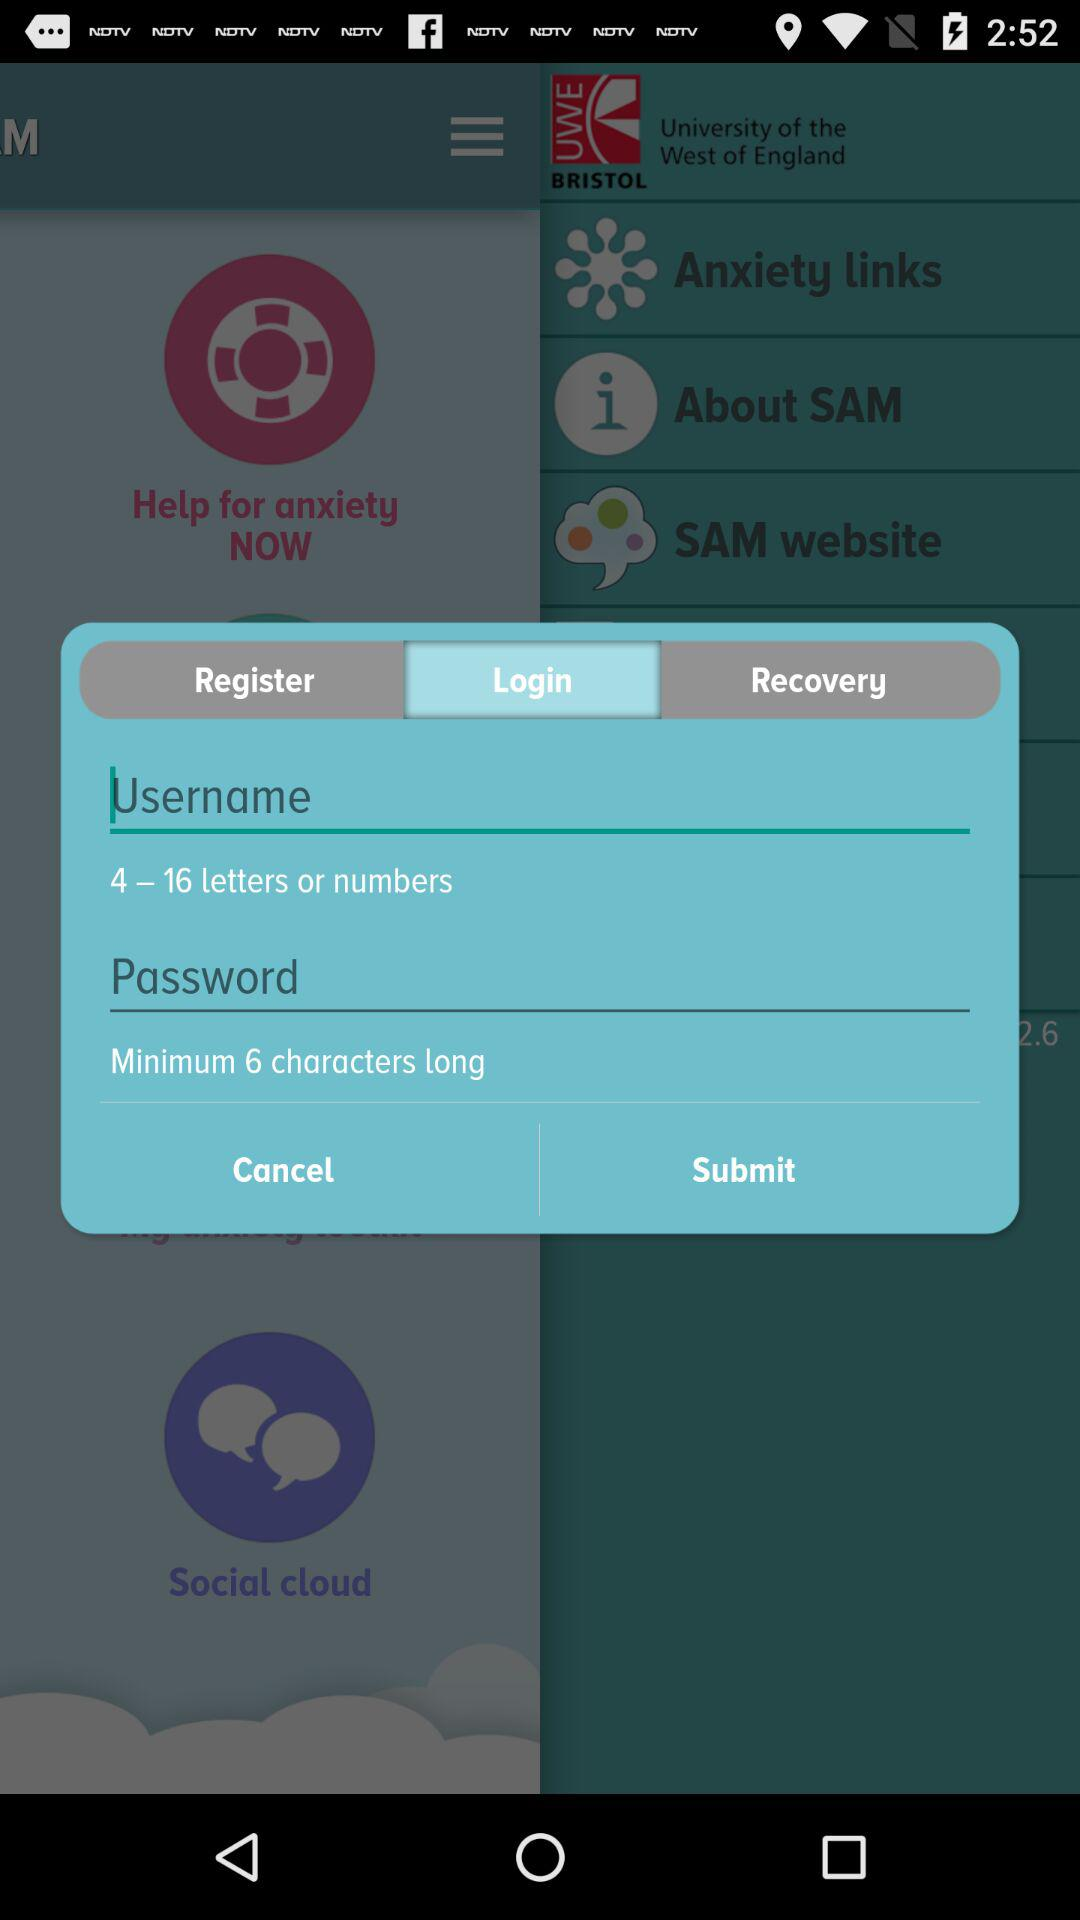What is the minimum number of characters required in a password? The minimum number of characters required is 6. 